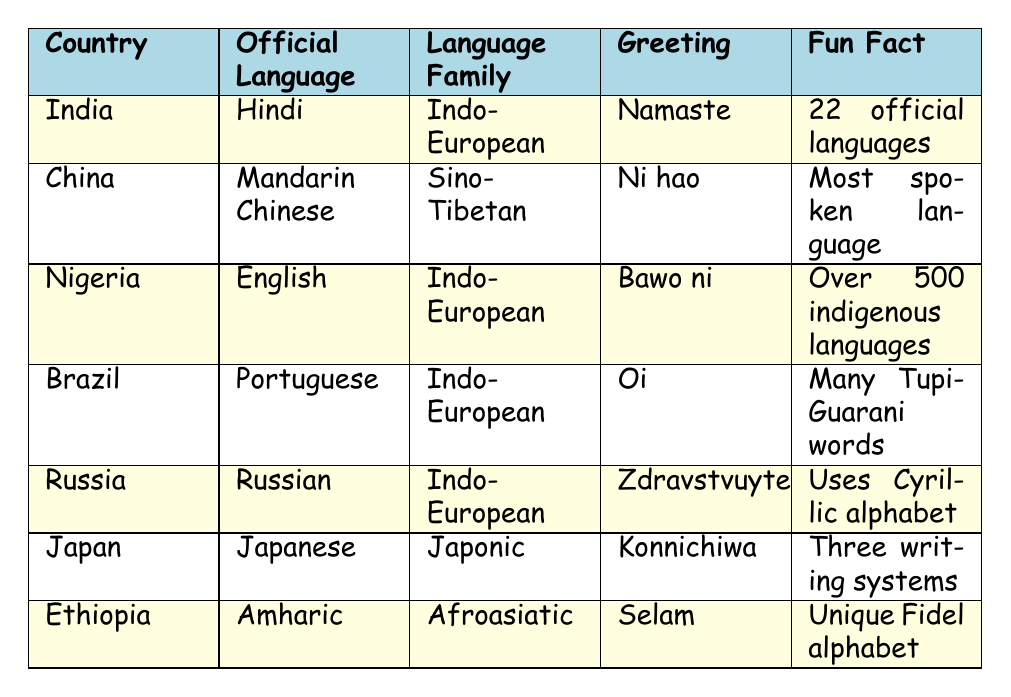What is the official language of Japan? The table lists the official language for each country. For Japan, it shows "Japanese" as the official language.
Answer: Japanese Which country has the most spoken language? The interesting fact column states that "Chinese is the most spoken language in the world," indicating that China is the country associated with this fact.
Answer: China How many languages are officially recognized in India? The table indicates that there are "22 official languages" in India.
Answer: 22 What language family does Russian belong to? According to the table, Russian is categorized under the "Indo-European" language family.
Answer: Indo-European List one common language spoken in Nigeria besides English. The table provides a list of "Other Common Languages" for Nigeria, which includes Hausa, Yoruba, and Igbo. Any of these could be accepted as an answer.
Answer: Hausa How many countries listed have Indo-European as their language family? By counting the entries in the table, we see that India, Nigeria, Brazil, and Russia all belong to the Indo-European family, which totals to four countries.
Answer: 4 What is the unique word or phrase used in Ethiopia? The table states that the unique word or phrase for greeting in Ethiopia is "Selam."
Answer: Selam Which two countries use languages from the Indo-European family? Looking at the table, India, Nigeria, Brazil, and Russia are found under the Indo-European language family. Therefore, any two from those countries can be used as an answer.
Answer: India and Brazil Does Japanese have only one writing system? The interesting fact for Japan mentions that "Japanese has three writing systems," therefore, the answer is no.
Answer: No What is the greeting used in China? The table lists the greeting for China as "Ni hao."
Answer: Ni hao Which country has a unique alphabet called Fidel? The data for Ethiopia indicates that Amharic has its own unique alphabet known as Fidel.
Answer: Ethiopia How many indigenous languages does Nigeria have? The table states that "Nigeria has over 500 indigenous languages," indicating a significant number.
Answer: Over 500 Which country speaks a language that has a greeting similar to "Oi"? The table indicates that Brazil uses "Oi" as a unique greeting phrase, linking it directly to that country.
Answer: Brazil What language family do the majority of countries in the table belong to? By evaluating the countries, we see that four out of the seven listed belong to the Indo-European family, thereby indicating it is the majority.
Answer: Indo-European Is there any country in the table associated with the Japonic language family? Yes, Japan is explicitly listed under the Japonic language family in the table.
Answer: Yes 